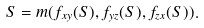Convert formula to latex. <formula><loc_0><loc_0><loc_500><loc_500>S = m ( f _ { x y } ( S ) , f _ { y z } ( S ) , f _ { z x } ( S ) ) .</formula> 